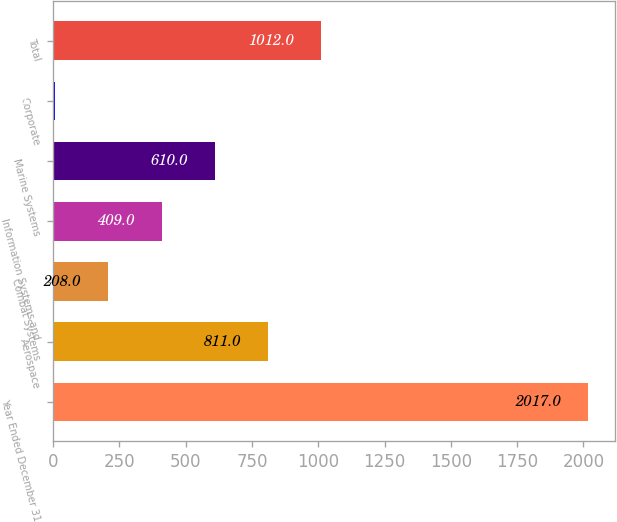Convert chart to OTSL. <chart><loc_0><loc_0><loc_500><loc_500><bar_chart><fcel>Year Ended December 31<fcel>Aerospace<fcel>Combat Systems<fcel>Information Systems and<fcel>Marine Systems<fcel>Corporate<fcel>Total<nl><fcel>2017<fcel>811<fcel>208<fcel>409<fcel>610<fcel>7<fcel>1012<nl></chart> 